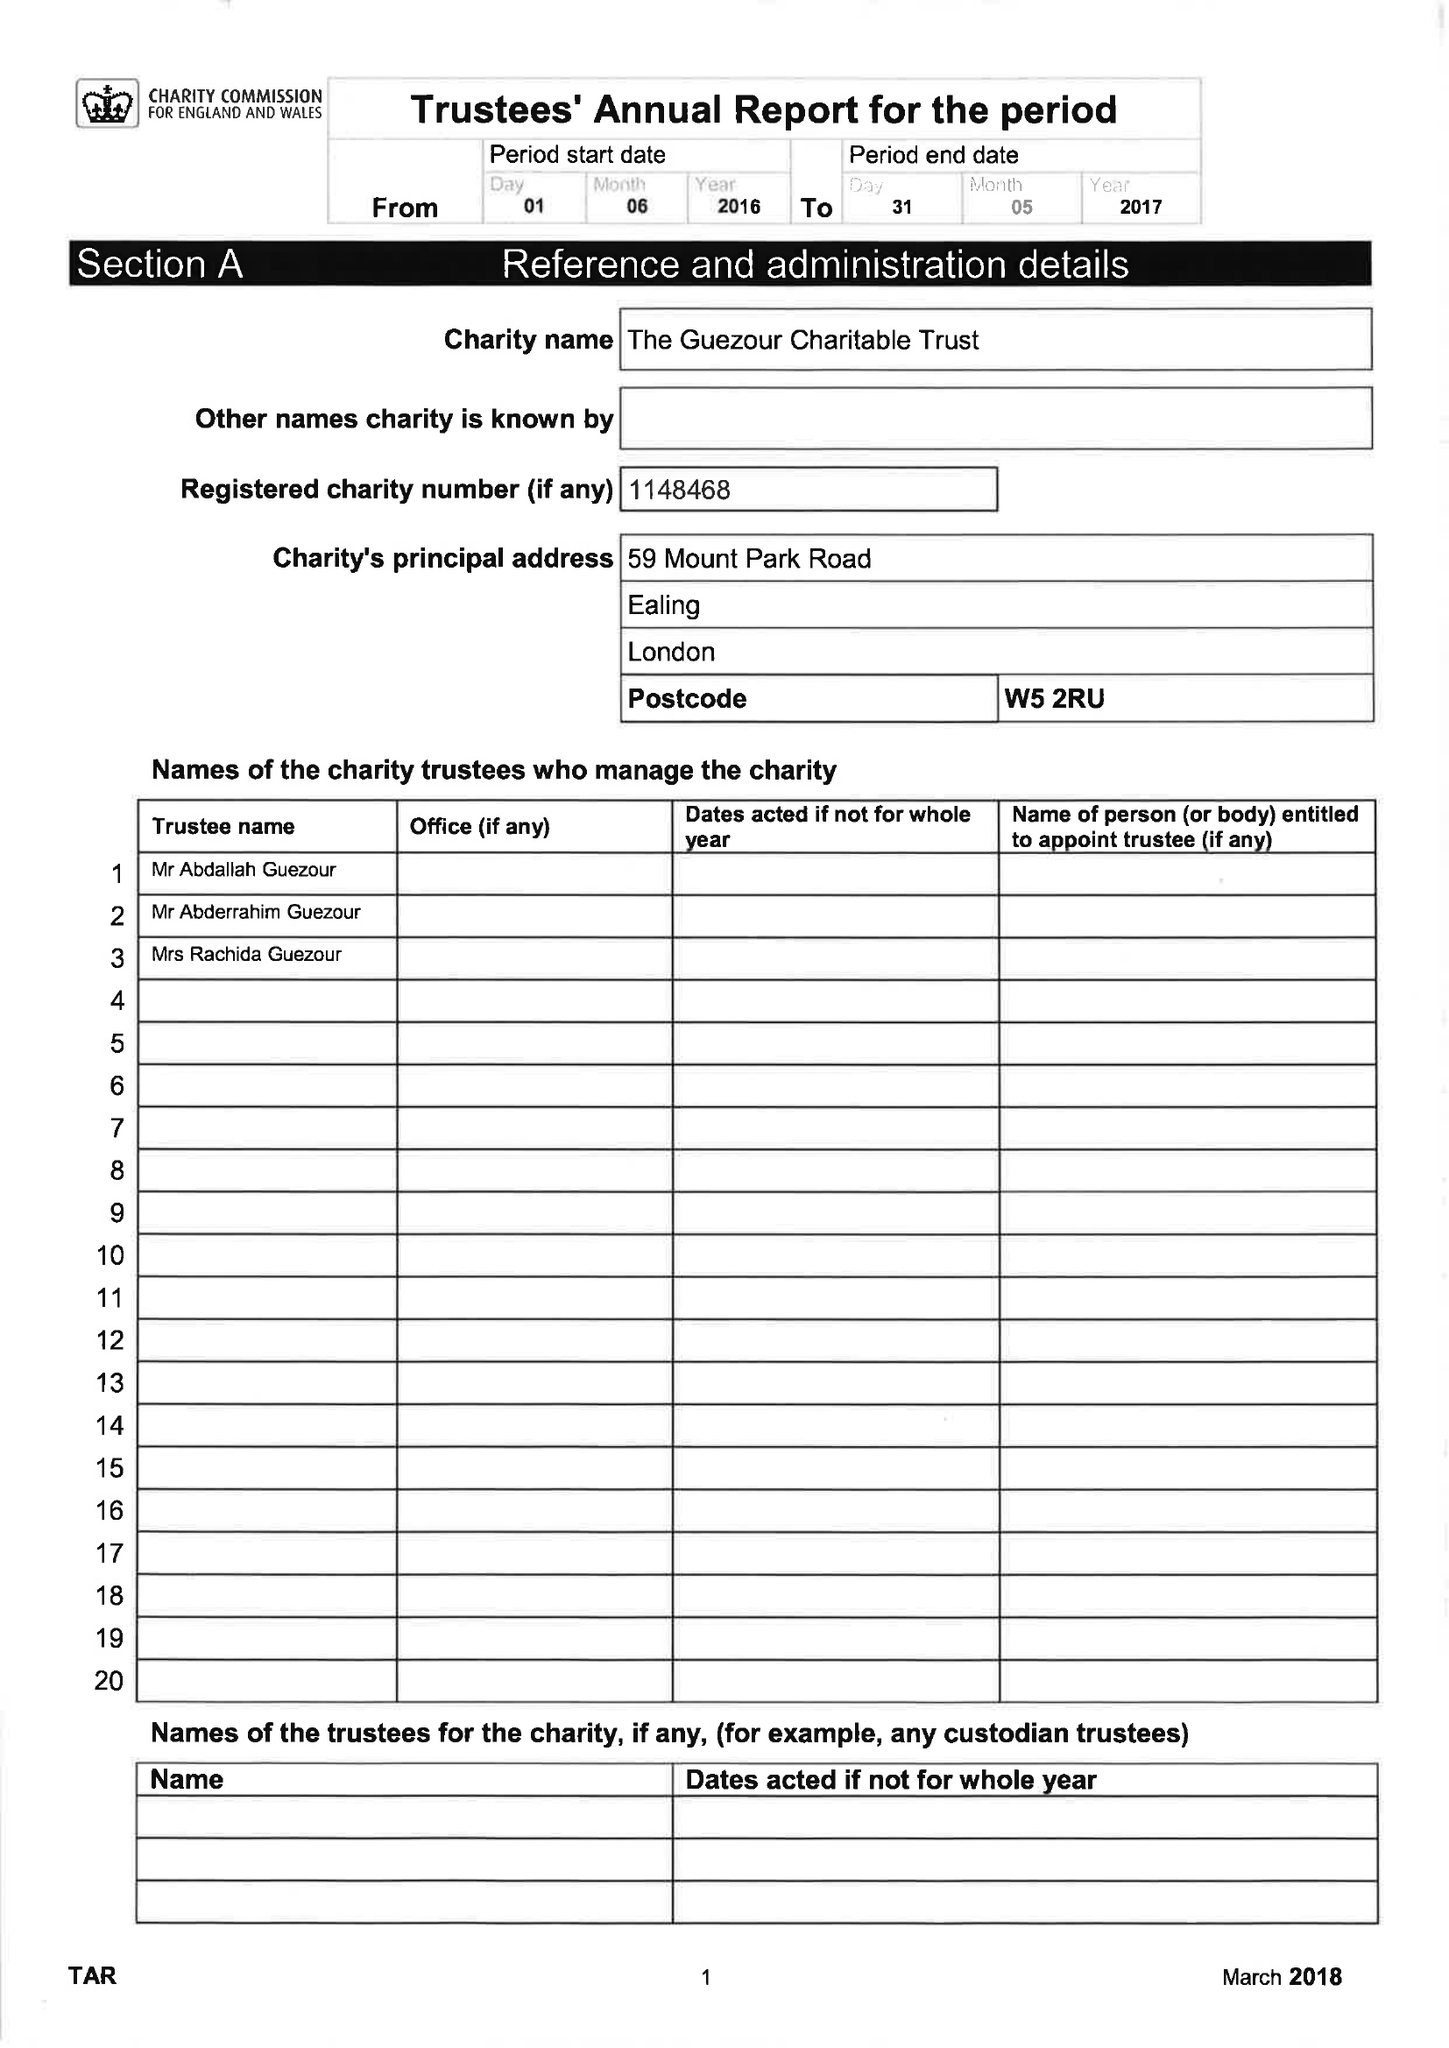What is the value for the spending_annually_in_british_pounds?
Answer the question using a single word or phrase. 222026.00 